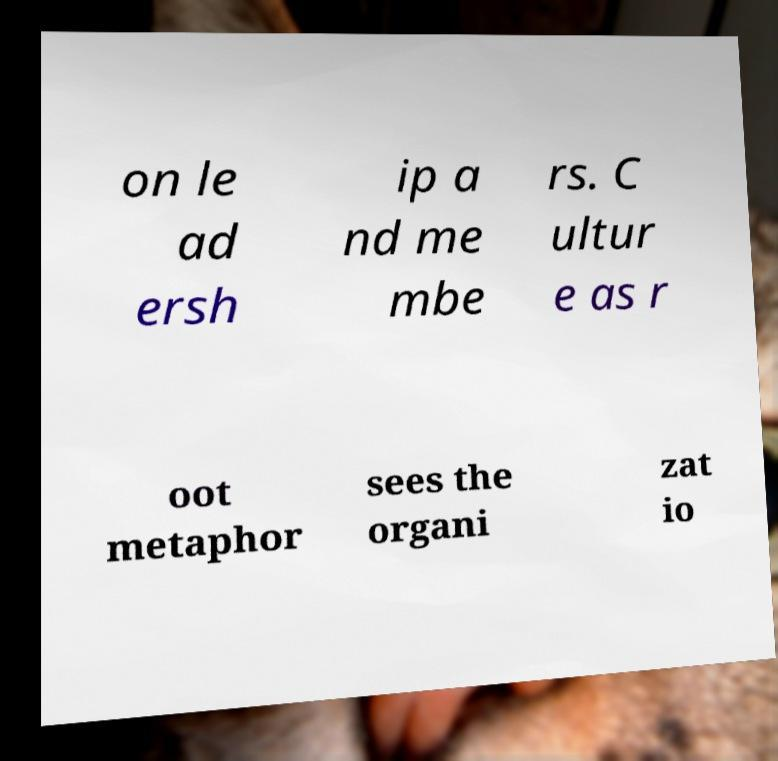What messages or text are displayed in this image? I need them in a readable, typed format. on le ad ersh ip a nd me mbe rs. C ultur e as r oot metaphor sees the organi zat io 